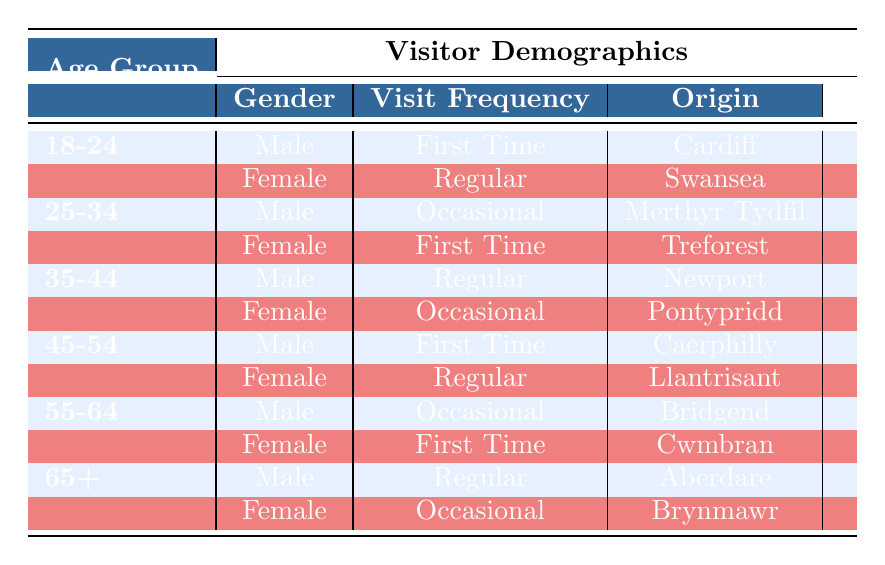What is the visit frequency of female visitors aged 18-24? From the table, we can see that female visitors aged 18-24 are listed as having a "Regular" visit frequency.
Answer: Regular How many first-time visits are reported for the age group 25-34? In the 25-34 age group, there is one first-time visitor, which is the female visitor from Treforest.
Answer: 1 True or False: There are more male visitors than female visitors in the 35-44 age group. In the table, both male and female visitors in the 35-44 age group have one representative each, making it equal. Therefore, the statement is false.
Answer: False What is the origin of the female visitor who is a regular in the age group 45-54? Referring to the table, the female visitor aged 45-54 has a regular visit frequency and is from Llantrisant.
Answer: Llantrisant How many visitors aged 55-64 have an occasional visit frequency? The table shows that there is one male visitor from Bridgend and one female visitor from Cwmbran, totaling to two visitors aged 55-64 with an occasional visit frequency.
Answer: 2 Which age group has the highest number of first-time visits? The 25-34 age group has two first-time visitors: one female from Treforest and one male from Caerphilly, indicating that this age group has the highest count of first-time visitors compared to others.
Answer: 25-34 What is the total number of visitors from Cardiff and Newport? The count of visitors from Cardiff and Newport sums to two: one male visitor from Cardiff and one male visitor from Newport.
Answer: 2 How many females are categorized as occasional visitors? In the data, the female visitors with an occasional visit frequency are those aged 35-44 from Pontypridd and those aged 65+ from Brynmawr; thus, there are two female occasional visitors.
Answer: 2 